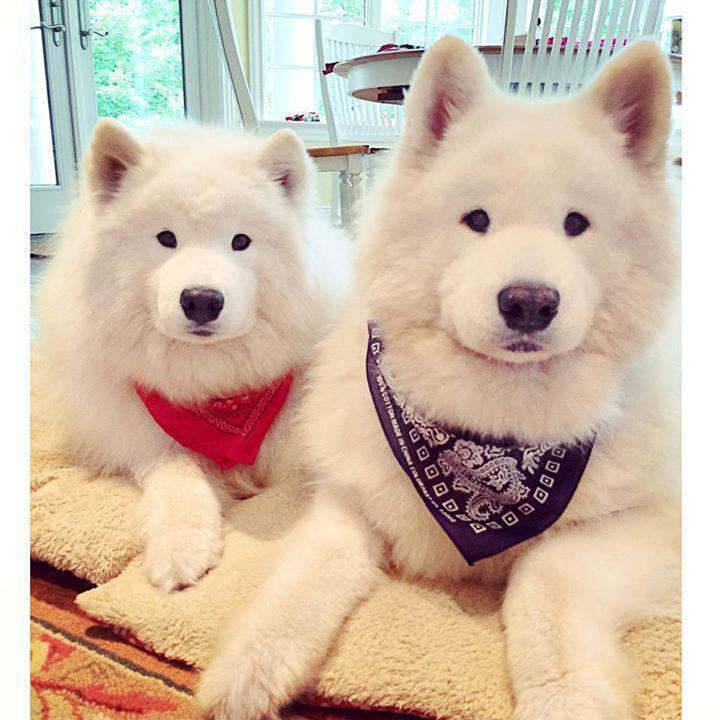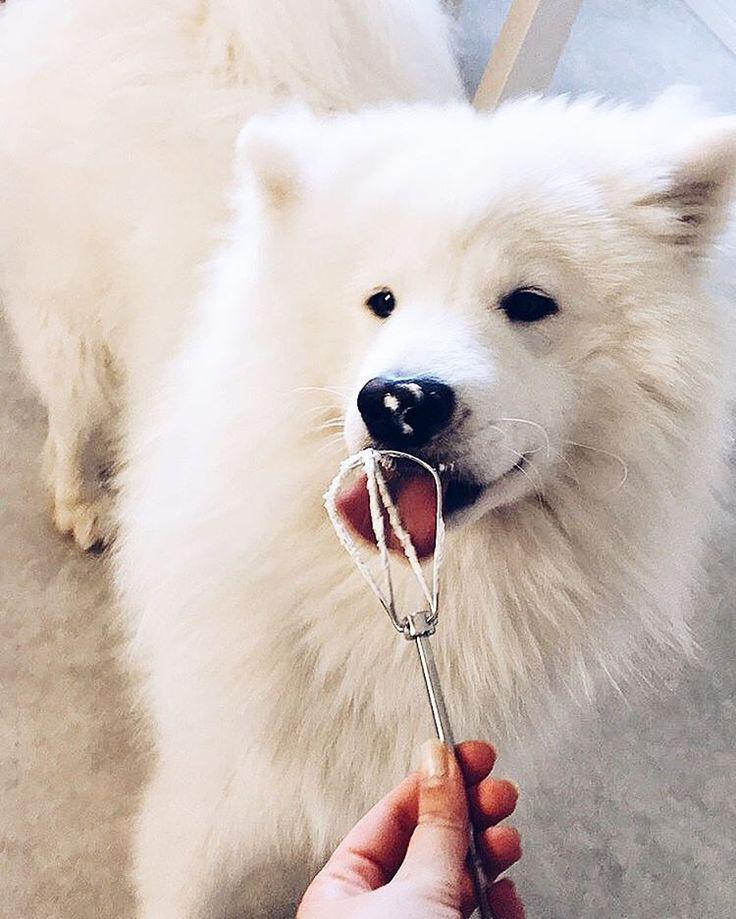The first image is the image on the left, the second image is the image on the right. For the images shown, is this caption "There are two dogs in total." true? Answer yes or no. No. The first image is the image on the left, the second image is the image on the right. Evaluate the accuracy of this statement regarding the images: "An image shows a white dog with something edible in front of him.". Is it true? Answer yes or no. Yes. 